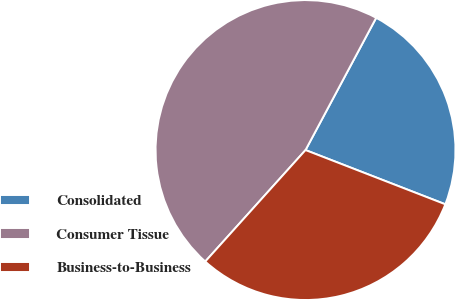<chart> <loc_0><loc_0><loc_500><loc_500><pie_chart><fcel>Consolidated<fcel>Consumer Tissue<fcel>Business-to-Business<nl><fcel>23.08%<fcel>46.15%<fcel>30.77%<nl></chart> 